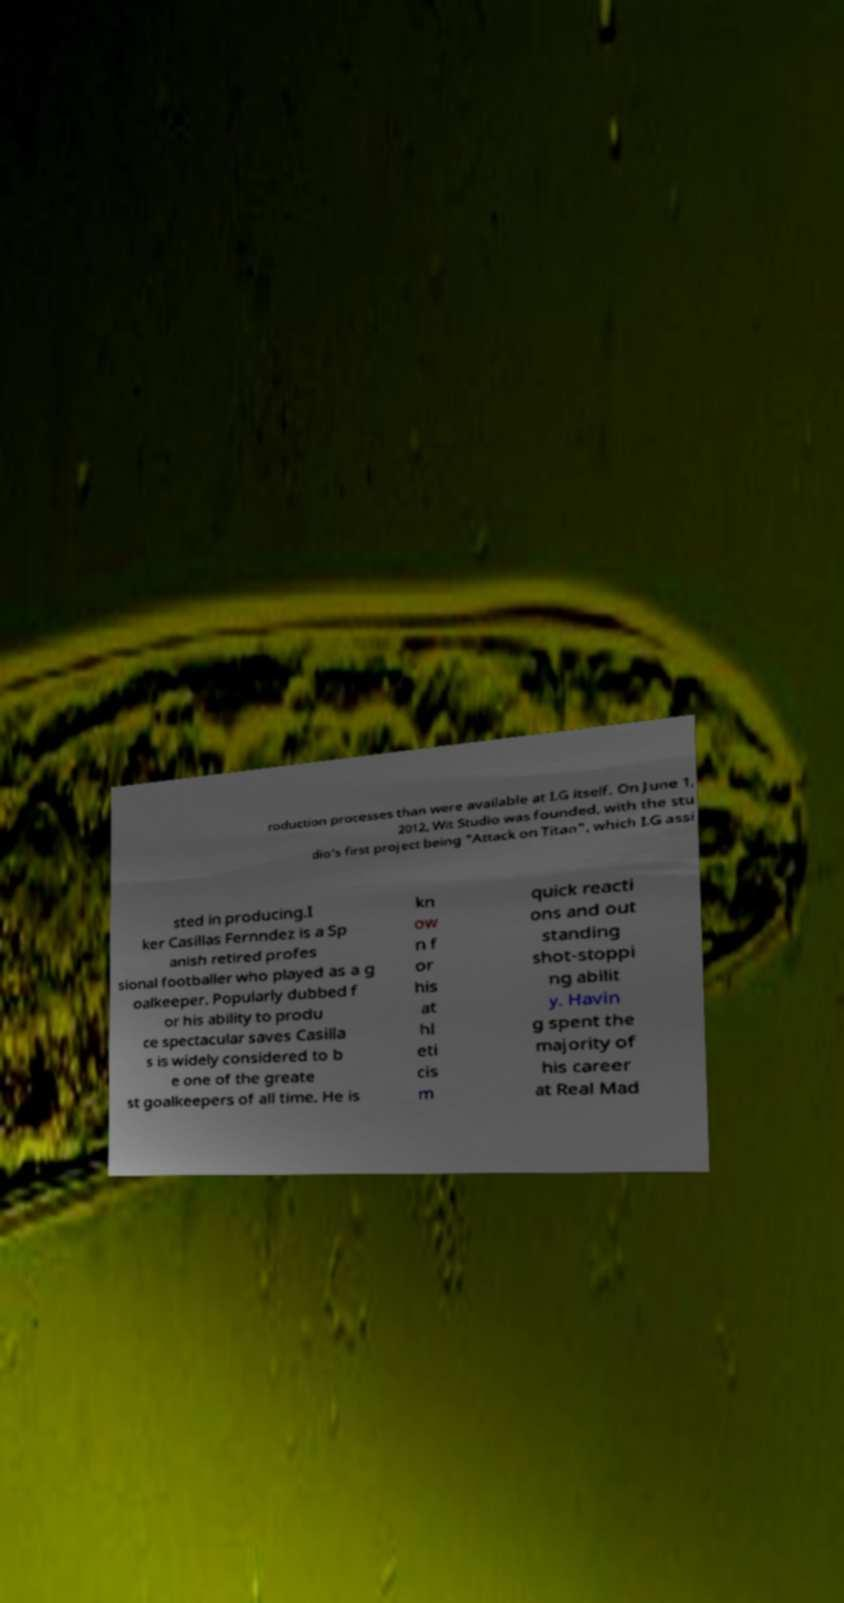Can you read and provide the text displayed in the image?This photo seems to have some interesting text. Can you extract and type it out for me? roduction processes than were available at I.G itself. On June 1, 2012, Wit Studio was founded, with the stu dio's first project being "Attack on Titan", which I.G assi sted in producing.I ker Casillas Fernndez is a Sp anish retired profes sional footballer who played as a g oalkeeper. Popularly dubbed f or his ability to produ ce spectacular saves Casilla s is widely considered to b e one of the greate st goalkeepers of all time. He is kn ow n f or his at hl eti cis m quick reacti ons and out standing shot-stoppi ng abilit y. Havin g spent the majority of his career at Real Mad 